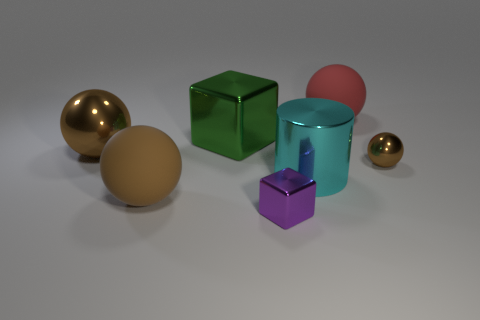The big metallic object that is the same shape as the big brown matte thing is what color?
Your answer should be compact. Brown. Is there anything else that has the same material as the large cube?
Make the answer very short. Yes. What is the size of the green object that is the same shape as the purple object?
Provide a succinct answer. Large. What is the thing on the right side of the red rubber sphere made of?
Your answer should be very brief. Metal. Are there fewer big red balls that are on the left side of the purple metallic cube than rubber spheres?
Offer a terse response. Yes. There is a big matte object that is to the left of the large ball to the right of the large green metal cube; what is its shape?
Offer a very short reply. Sphere. What color is the big cylinder?
Your answer should be very brief. Cyan. How many other things are there of the same size as the red sphere?
Keep it short and to the point. 4. What is the thing that is both in front of the small brown thing and on the left side of the small purple block made of?
Ensure brevity in your answer.  Rubber. There is a matte thing in front of the red thing; is it the same size as the big red matte object?
Keep it short and to the point. Yes. 